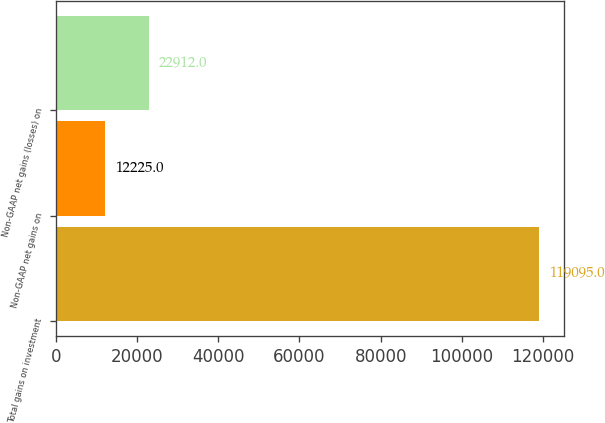<chart> <loc_0><loc_0><loc_500><loc_500><bar_chart><fcel>Total gains on investment<fcel>Non-GAAP net gains on<fcel>Non-GAAP net gains (losses) on<nl><fcel>119095<fcel>12225<fcel>22912<nl></chart> 